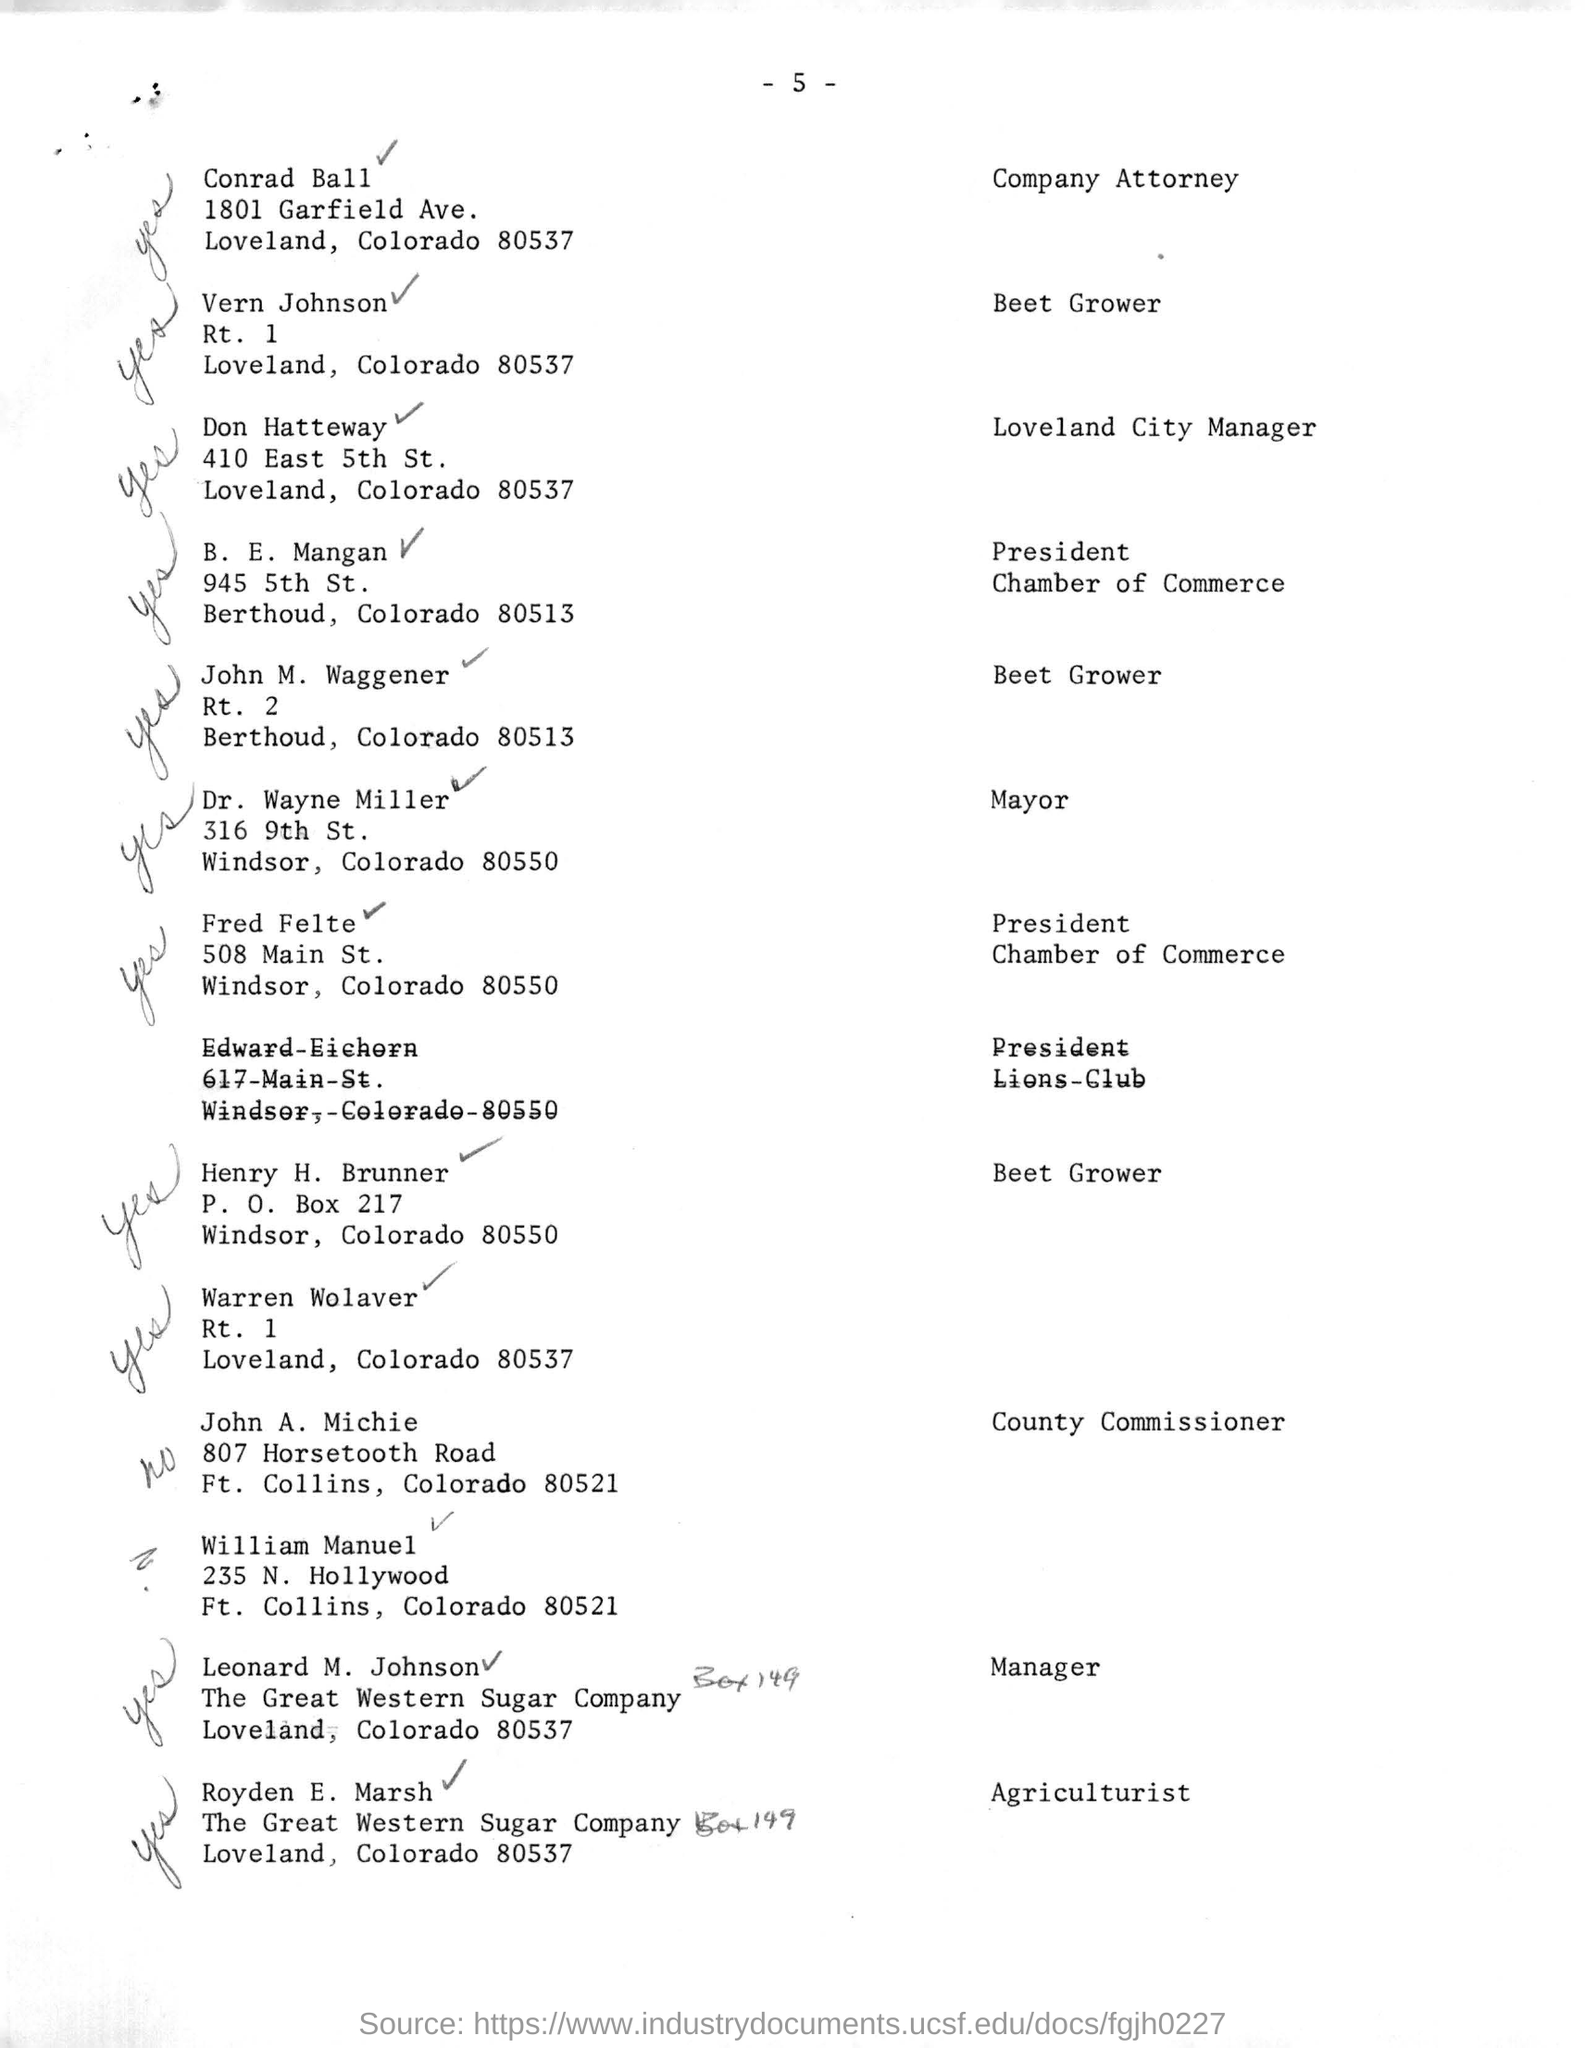What is the designation of Leonard M. Johnson?
Give a very brief answer. Manager. Who is the Company Attorney?
Provide a succinct answer. Conrad Ball. What is the page no mentioned in this document?
Your answer should be compact. - 5 -. What is the designation of Royden E. Marsh?
Give a very brief answer. Agriculturist. Who is the President of Chamber of Commerce?
Give a very brief answer. Fred Felte. 